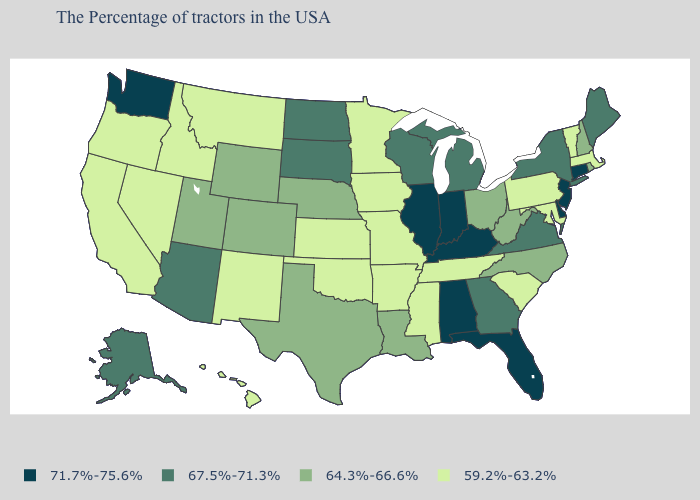What is the lowest value in the USA?
Short answer required. 59.2%-63.2%. What is the lowest value in the West?
Short answer required. 59.2%-63.2%. What is the value of Rhode Island?
Write a very short answer. 64.3%-66.6%. What is the value of Massachusetts?
Short answer required. 59.2%-63.2%. Does Oregon have the highest value in the USA?
Be succinct. No. Name the states that have a value in the range 67.5%-71.3%?
Keep it brief. Maine, New York, Virginia, Georgia, Michigan, Wisconsin, South Dakota, North Dakota, Arizona, Alaska. Name the states that have a value in the range 71.7%-75.6%?
Answer briefly. Connecticut, New Jersey, Delaware, Florida, Kentucky, Indiana, Alabama, Illinois, Washington. Among the states that border Colorado , which have the lowest value?
Write a very short answer. Kansas, Oklahoma, New Mexico. Among the states that border Delaware , does Pennsylvania have the lowest value?
Keep it brief. Yes. Among the states that border New York , which have the lowest value?
Write a very short answer. Massachusetts, Vermont, Pennsylvania. What is the value of Florida?
Answer briefly. 71.7%-75.6%. Which states have the highest value in the USA?
Concise answer only. Connecticut, New Jersey, Delaware, Florida, Kentucky, Indiana, Alabama, Illinois, Washington. What is the highest value in the USA?
Quick response, please. 71.7%-75.6%. Which states have the lowest value in the Northeast?
Quick response, please. Massachusetts, Vermont, Pennsylvania. 